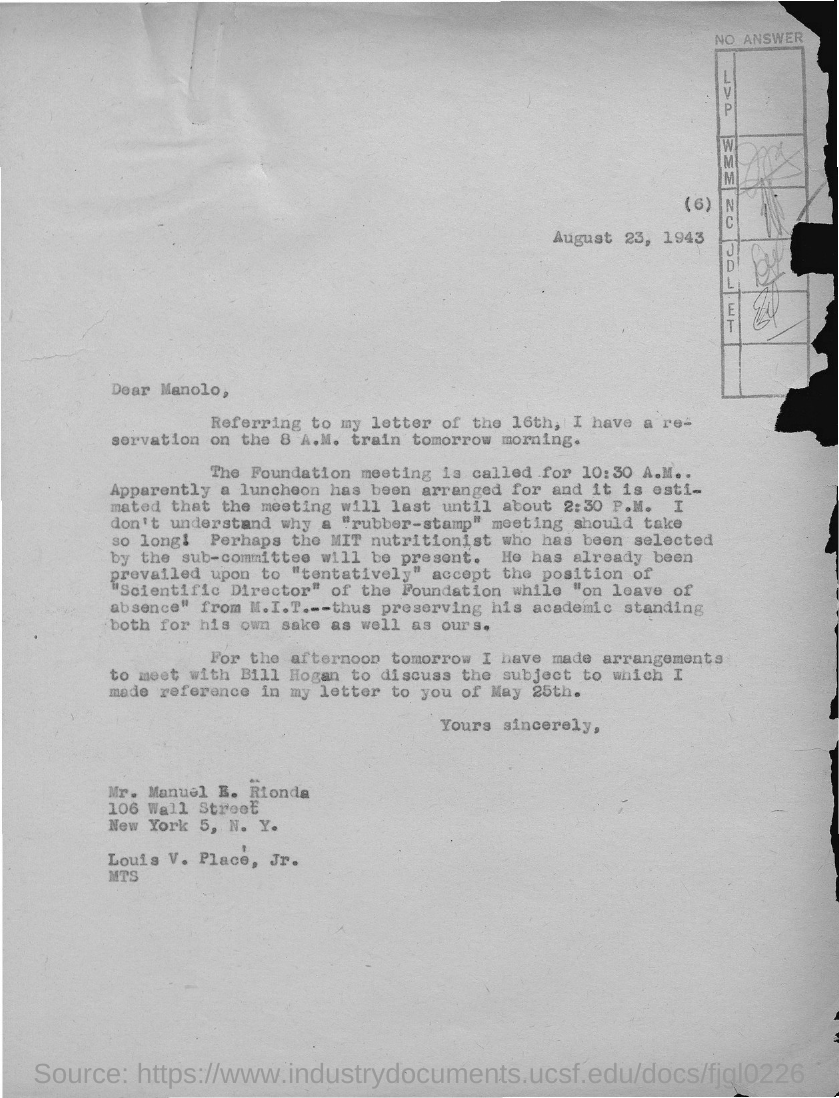Indicate a few pertinent items in this graphic. The letter is addressed to Mr. Manuel E. Rionda. The date on the document is August 23, 1943. It is clear that a meeting has been arranged between unknown individuals, and the person specified in the text is Bill Hogan. The Foundation meeting is called at 10:30 A.M. The meeting is expected to last until approximately 2:30 P.M. 